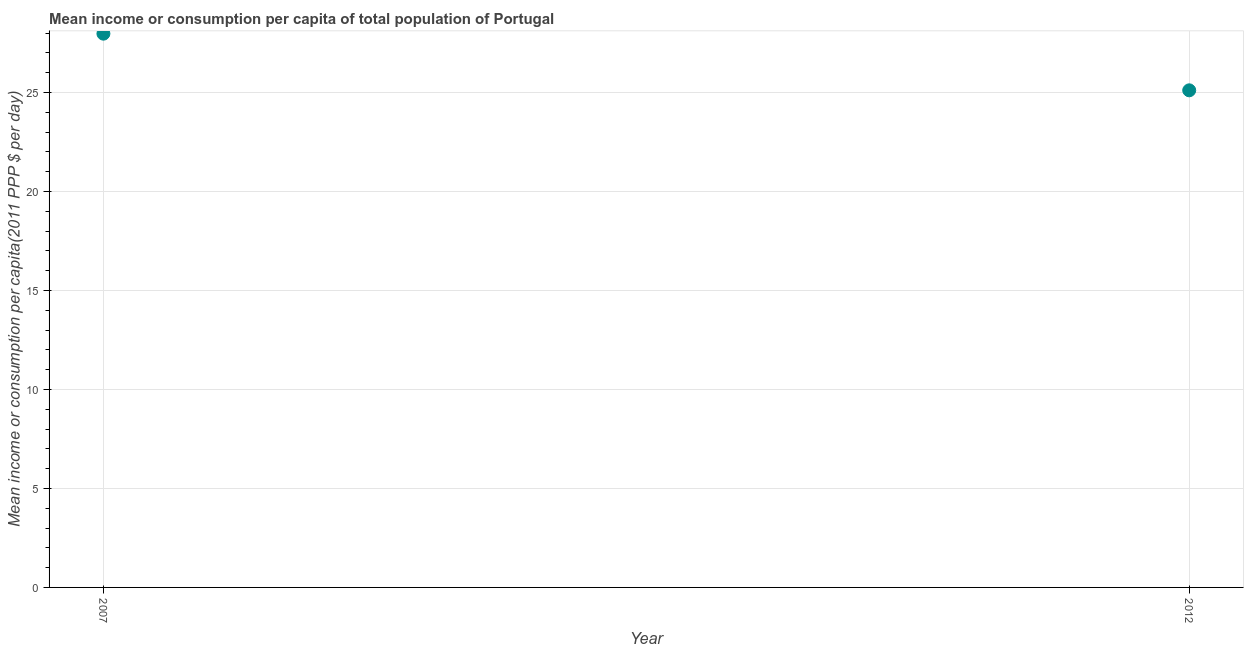What is the mean income or consumption in 2012?
Keep it short and to the point. 25.11. Across all years, what is the maximum mean income or consumption?
Offer a very short reply. 27.97. Across all years, what is the minimum mean income or consumption?
Give a very brief answer. 25.11. In which year was the mean income or consumption maximum?
Offer a terse response. 2007. In which year was the mean income or consumption minimum?
Give a very brief answer. 2012. What is the sum of the mean income or consumption?
Offer a terse response. 53.08. What is the difference between the mean income or consumption in 2007 and 2012?
Make the answer very short. 2.86. What is the average mean income or consumption per year?
Your answer should be very brief. 26.54. What is the median mean income or consumption?
Keep it short and to the point. 26.54. In how many years, is the mean income or consumption greater than 10 $?
Ensure brevity in your answer.  2. Do a majority of the years between 2007 and 2012 (inclusive) have mean income or consumption greater than 7 $?
Provide a succinct answer. Yes. What is the ratio of the mean income or consumption in 2007 to that in 2012?
Make the answer very short. 1.11. Is the mean income or consumption in 2007 less than that in 2012?
Give a very brief answer. No. In how many years, is the mean income or consumption greater than the average mean income or consumption taken over all years?
Provide a succinct answer. 1. Does the mean income or consumption monotonically increase over the years?
Provide a succinct answer. No. How many dotlines are there?
Keep it short and to the point. 1. How many years are there in the graph?
Provide a short and direct response. 2. What is the difference between two consecutive major ticks on the Y-axis?
Ensure brevity in your answer.  5. What is the title of the graph?
Give a very brief answer. Mean income or consumption per capita of total population of Portugal. What is the label or title of the X-axis?
Offer a terse response. Year. What is the label or title of the Y-axis?
Ensure brevity in your answer.  Mean income or consumption per capita(2011 PPP $ per day). What is the Mean income or consumption per capita(2011 PPP $ per day) in 2007?
Offer a very short reply. 27.97. What is the Mean income or consumption per capita(2011 PPP $ per day) in 2012?
Offer a very short reply. 25.11. What is the difference between the Mean income or consumption per capita(2011 PPP $ per day) in 2007 and 2012?
Make the answer very short. 2.86. What is the ratio of the Mean income or consumption per capita(2011 PPP $ per day) in 2007 to that in 2012?
Keep it short and to the point. 1.11. 